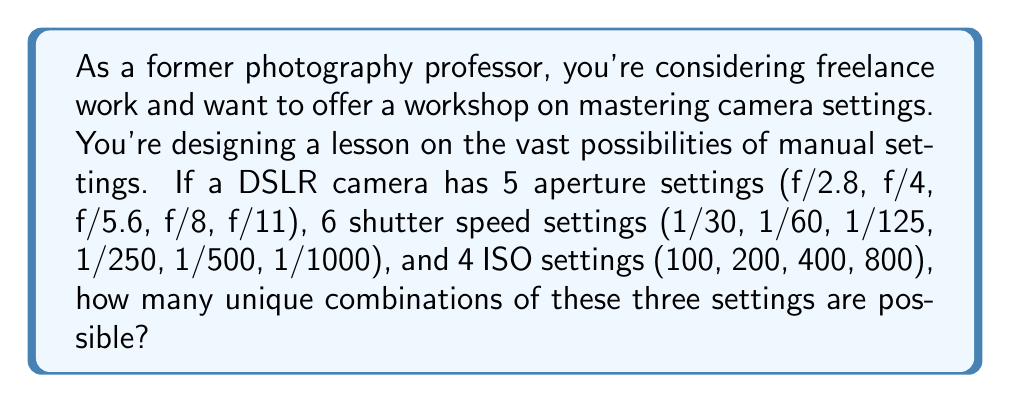Show me your answer to this math problem. To solve this problem, we'll use the multiplication principle of counting. This principle states that if we have $m$ ways of doing something and $n$ ways of doing another thing, then there are $m \times n$ ways of doing both things.

Let's break down the information given:
1. Aperture settings: 5 options
2. Shutter speed settings: 6 options
3. ISO settings: 4 options

For each photograph, we need to choose one option from each of these three categories. The number of possible combinations is therefore:

$$\text{Total combinations} = \text{Aperture options} \times \text{Shutter speed options} \times \text{ISO options}$$

Substituting the values:

$$\text{Total combinations} = 5 \times 6 \times 4$$

Calculating:

$$\text{Total combinations} = 120$$

This means that there are 120 unique combinations of aperture, shutter speed, and ISO settings possible with the given options.
Answer: 120 unique combinations 